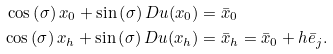<formula> <loc_0><loc_0><loc_500><loc_500>\cos \left ( \sigma \right ) x _ { 0 } + \sin \left ( \sigma \right ) D u ( x _ { 0 } ) & = \bar { x } _ { 0 } \\ \cos \left ( \sigma \right ) x _ { h } + \sin \left ( \sigma \right ) D u ( x _ { h } ) & = \bar { x } _ { h } = \bar { x } _ { 0 } + h \bar { e } _ { j } .</formula> 